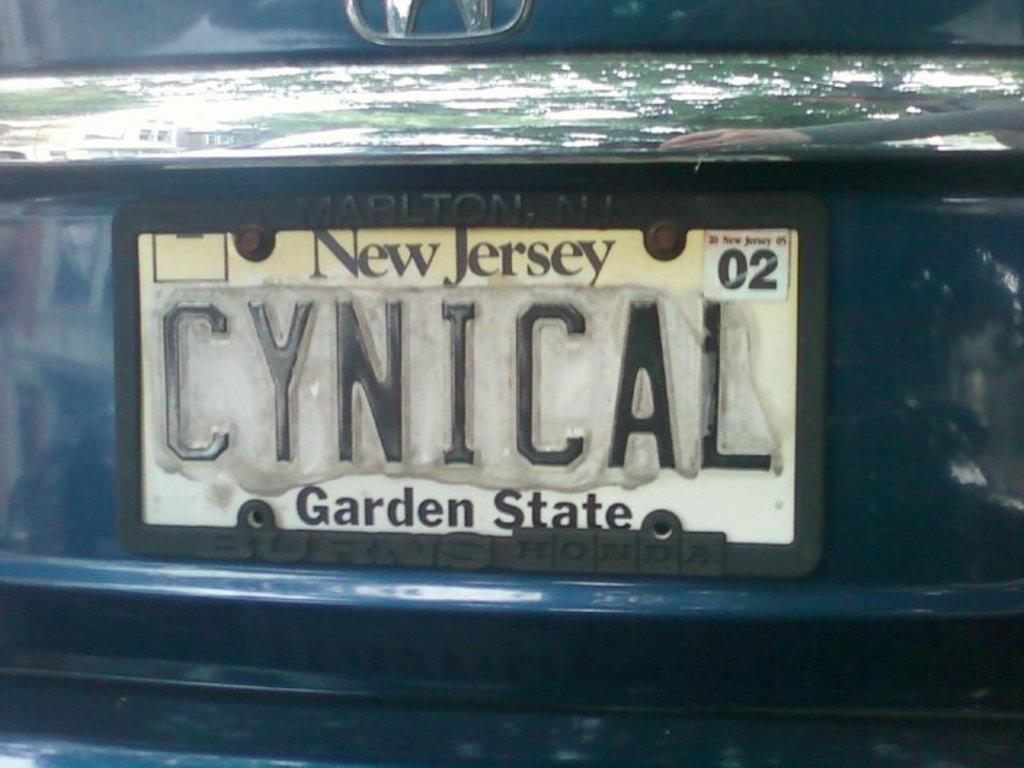Provide a one-sentence caption for the provided image. the Garden State license plate that is on the back of a car. 